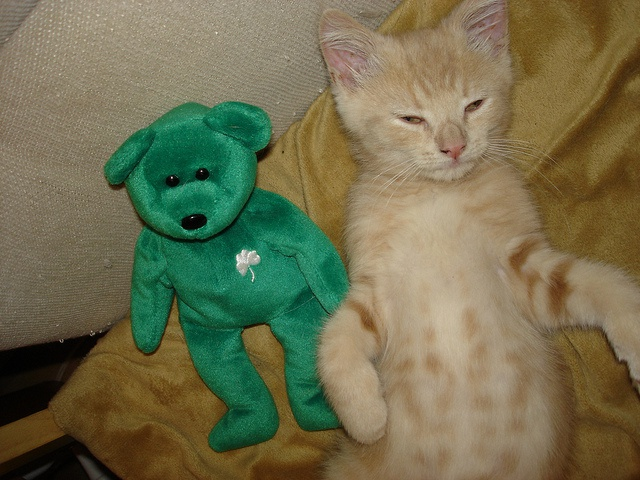Describe the objects in this image and their specific colors. I can see cat in gray, tan, and olive tones, couch in gray and darkgray tones, couch in gray, olive, and maroon tones, and teddy bear in gray, darkgreen, teal, and black tones in this image. 